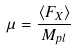Convert formula to latex. <formula><loc_0><loc_0><loc_500><loc_500>\mu = \frac { \langle F _ { X } \rangle } { M _ { p l } }</formula> 